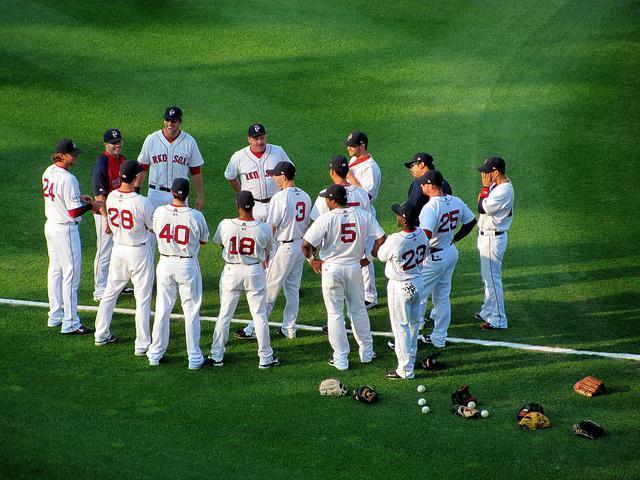Which equipment would be fastest for them to use?
Make your selection and explain in format: 'Answer: answer
Rationale: rationale.'
Options: Mitts, shoes, baseball bats, balls. Answer: shoes.
Rationale: A bunch of pro baseball players are standing on the field. they are wearing things on the feet that make them run fast. 